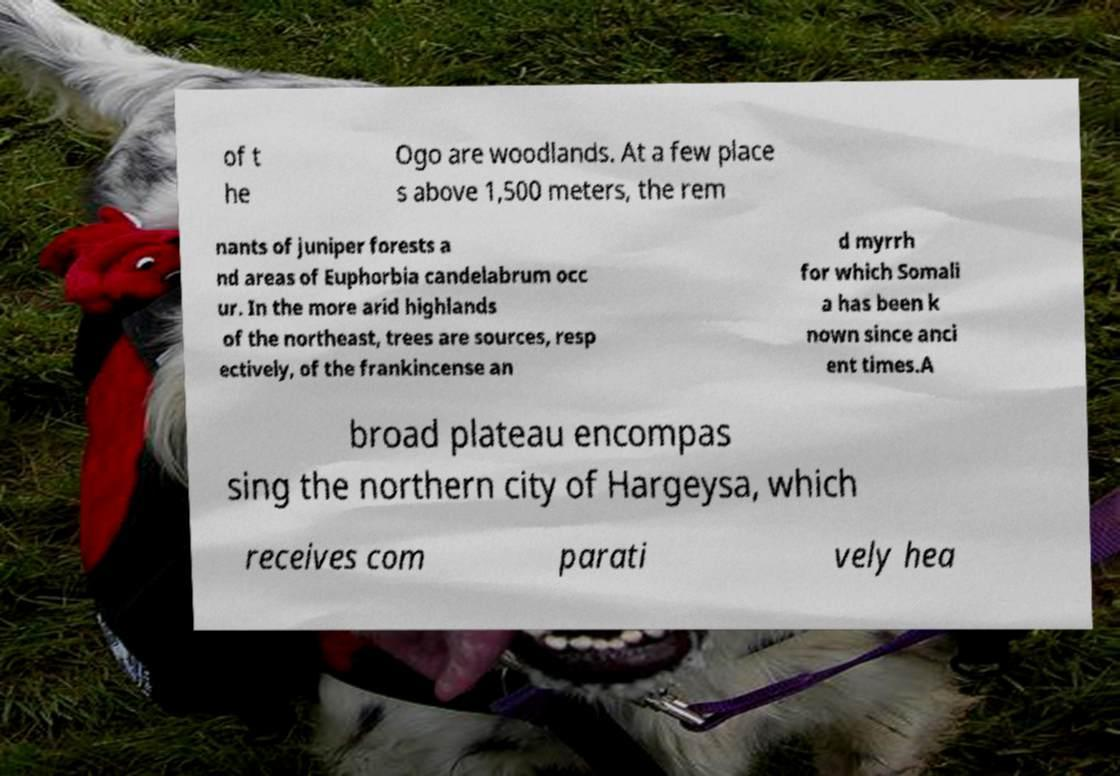Please identify and transcribe the text found in this image. of t he Ogo are woodlands. At a few place s above 1,500 meters, the rem nants of juniper forests a nd areas of Euphorbia candelabrum occ ur. In the more arid highlands of the northeast, trees are sources, resp ectively, of the frankincense an d myrrh for which Somali a has been k nown since anci ent times.A broad plateau encompas sing the northern city of Hargeysa, which receives com parati vely hea 